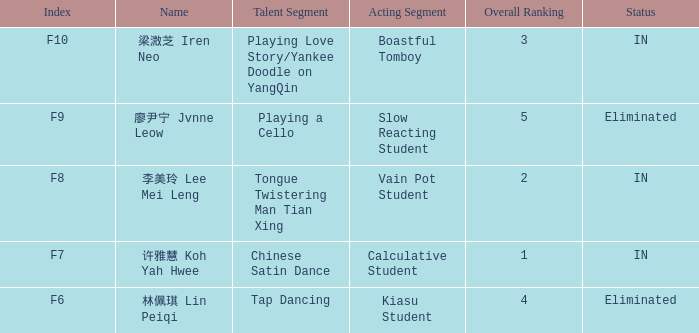For all events with index f10, what is the sum of the overall rankings? 3.0. 